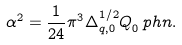<formula> <loc_0><loc_0><loc_500><loc_500>\alpha ^ { 2 } = \frac { 1 } { 2 4 } \pi ^ { 3 } \Delta ^ { 1 / 2 } _ { q , 0 } Q _ { 0 } ^ { \ } p h n .</formula> 